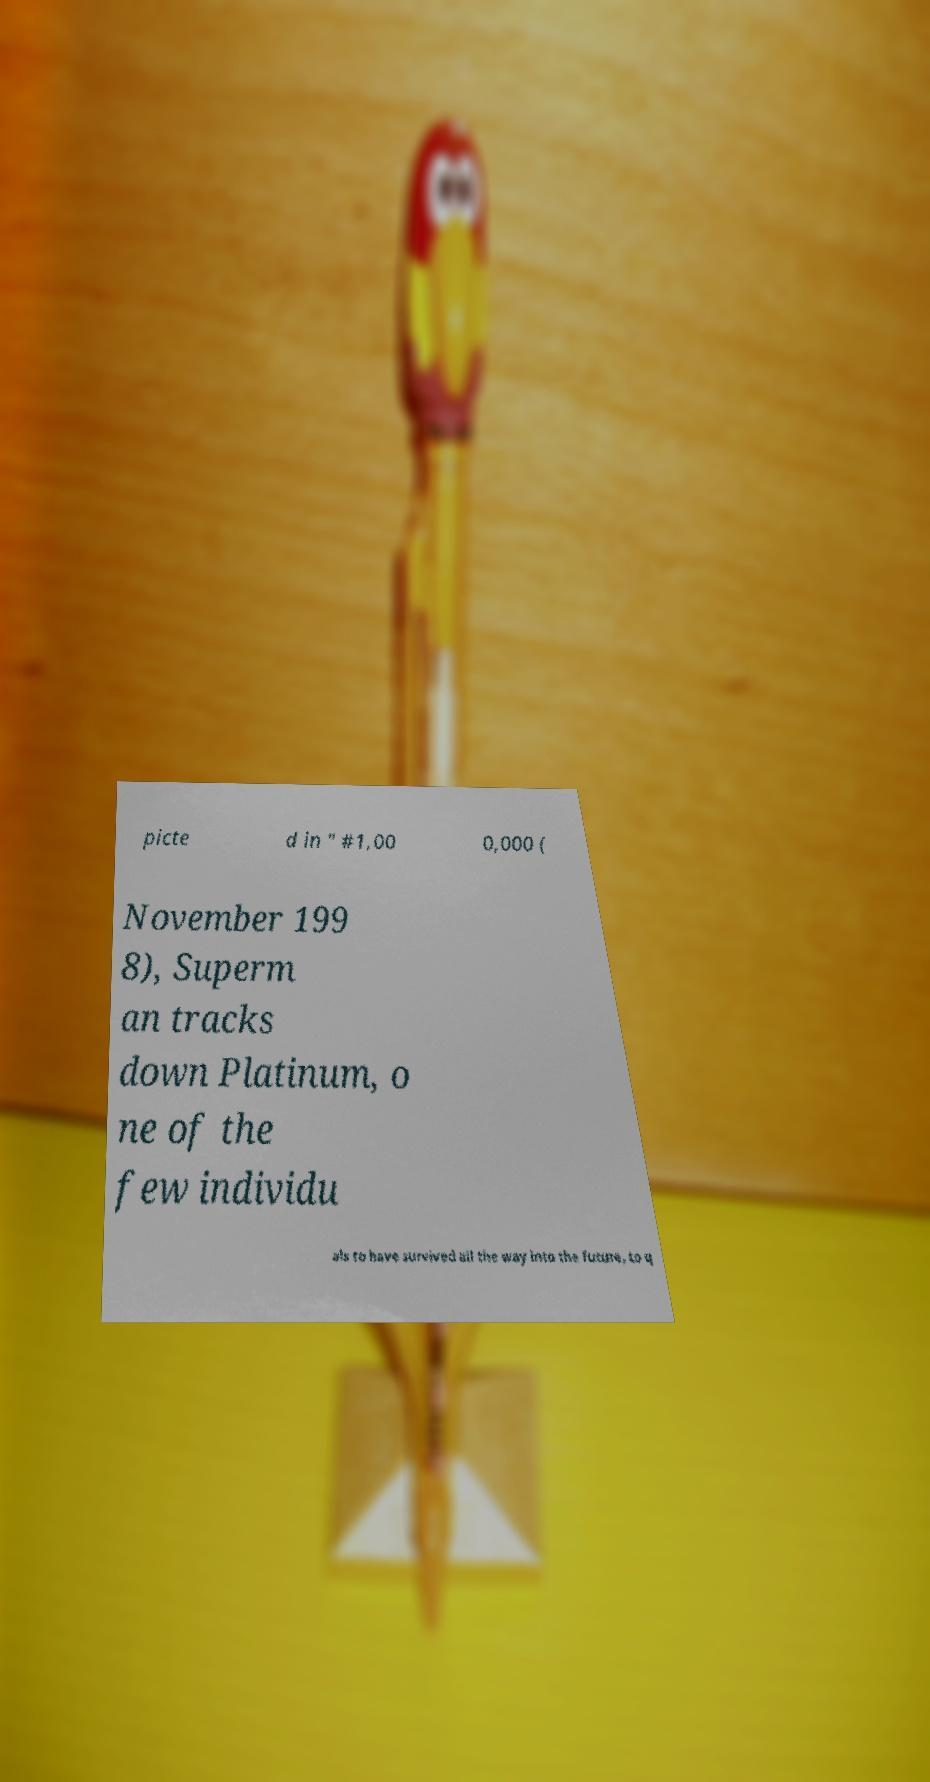I need the written content from this picture converted into text. Can you do that? picte d in " #1,00 0,000 ( November 199 8), Superm an tracks down Platinum, o ne of the few individu als to have survived all the way into the future, to q 